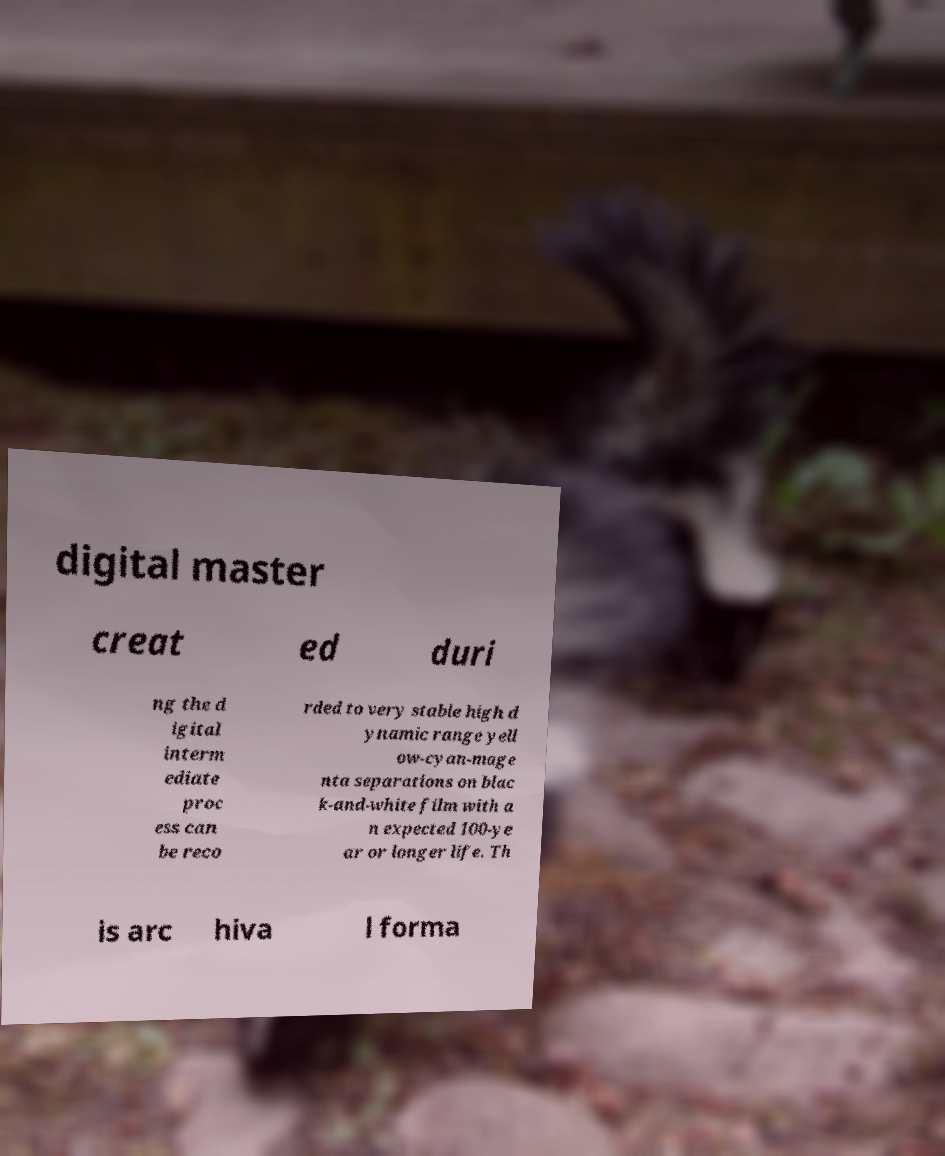Can you accurately transcribe the text from the provided image for me? digital master creat ed duri ng the d igital interm ediate proc ess can be reco rded to very stable high d ynamic range yell ow-cyan-mage nta separations on blac k-and-white film with a n expected 100-ye ar or longer life. Th is arc hiva l forma 